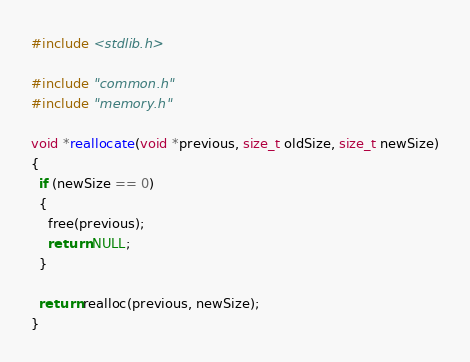<code> <loc_0><loc_0><loc_500><loc_500><_C_>#include <stdlib.h>

#include "common.h"
#include "memory.h"

void *reallocate(void *previous, size_t oldSize, size_t newSize)
{
  if (newSize == 0)
  {
    free(previous);
    return NULL;
  }

  return realloc(previous, newSize);
}
</code> 